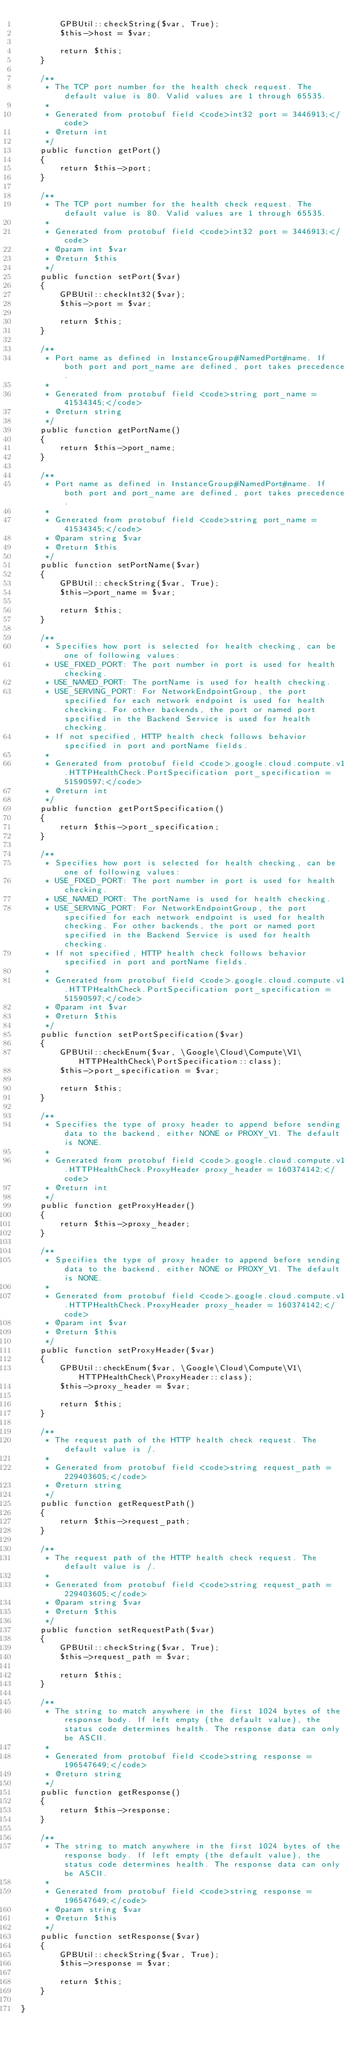<code> <loc_0><loc_0><loc_500><loc_500><_PHP_>        GPBUtil::checkString($var, True);
        $this->host = $var;

        return $this;
    }

    /**
     * The TCP port number for the health check request. The default value is 80. Valid values are 1 through 65535.
     *
     * Generated from protobuf field <code>int32 port = 3446913;</code>
     * @return int
     */
    public function getPort()
    {
        return $this->port;
    }

    /**
     * The TCP port number for the health check request. The default value is 80. Valid values are 1 through 65535.
     *
     * Generated from protobuf field <code>int32 port = 3446913;</code>
     * @param int $var
     * @return $this
     */
    public function setPort($var)
    {
        GPBUtil::checkInt32($var);
        $this->port = $var;

        return $this;
    }

    /**
     * Port name as defined in InstanceGroup#NamedPort#name. If both port and port_name are defined, port takes precedence.
     *
     * Generated from protobuf field <code>string port_name = 41534345;</code>
     * @return string
     */
    public function getPortName()
    {
        return $this->port_name;
    }

    /**
     * Port name as defined in InstanceGroup#NamedPort#name. If both port and port_name are defined, port takes precedence.
     *
     * Generated from protobuf field <code>string port_name = 41534345;</code>
     * @param string $var
     * @return $this
     */
    public function setPortName($var)
    {
        GPBUtil::checkString($var, True);
        $this->port_name = $var;

        return $this;
    }

    /**
     * Specifies how port is selected for health checking, can be one of following values:
     * USE_FIXED_PORT: The port number in port is used for health checking.
     * USE_NAMED_PORT: The portName is used for health checking.
     * USE_SERVING_PORT: For NetworkEndpointGroup, the port specified for each network endpoint is used for health checking. For other backends, the port or named port specified in the Backend Service is used for health checking.
     * If not specified, HTTP health check follows behavior specified in port and portName fields.
     *
     * Generated from protobuf field <code>.google.cloud.compute.v1.HTTPHealthCheck.PortSpecification port_specification = 51590597;</code>
     * @return int
     */
    public function getPortSpecification()
    {
        return $this->port_specification;
    }

    /**
     * Specifies how port is selected for health checking, can be one of following values:
     * USE_FIXED_PORT: The port number in port is used for health checking.
     * USE_NAMED_PORT: The portName is used for health checking.
     * USE_SERVING_PORT: For NetworkEndpointGroup, the port specified for each network endpoint is used for health checking. For other backends, the port or named port specified in the Backend Service is used for health checking.
     * If not specified, HTTP health check follows behavior specified in port and portName fields.
     *
     * Generated from protobuf field <code>.google.cloud.compute.v1.HTTPHealthCheck.PortSpecification port_specification = 51590597;</code>
     * @param int $var
     * @return $this
     */
    public function setPortSpecification($var)
    {
        GPBUtil::checkEnum($var, \Google\Cloud\Compute\V1\HTTPHealthCheck\PortSpecification::class);
        $this->port_specification = $var;

        return $this;
    }

    /**
     * Specifies the type of proxy header to append before sending data to the backend, either NONE or PROXY_V1. The default is NONE.
     *
     * Generated from protobuf field <code>.google.cloud.compute.v1.HTTPHealthCheck.ProxyHeader proxy_header = 160374142;</code>
     * @return int
     */
    public function getProxyHeader()
    {
        return $this->proxy_header;
    }

    /**
     * Specifies the type of proxy header to append before sending data to the backend, either NONE or PROXY_V1. The default is NONE.
     *
     * Generated from protobuf field <code>.google.cloud.compute.v1.HTTPHealthCheck.ProxyHeader proxy_header = 160374142;</code>
     * @param int $var
     * @return $this
     */
    public function setProxyHeader($var)
    {
        GPBUtil::checkEnum($var, \Google\Cloud\Compute\V1\HTTPHealthCheck\ProxyHeader::class);
        $this->proxy_header = $var;

        return $this;
    }

    /**
     * The request path of the HTTP health check request. The default value is /.
     *
     * Generated from protobuf field <code>string request_path = 229403605;</code>
     * @return string
     */
    public function getRequestPath()
    {
        return $this->request_path;
    }

    /**
     * The request path of the HTTP health check request. The default value is /.
     *
     * Generated from protobuf field <code>string request_path = 229403605;</code>
     * @param string $var
     * @return $this
     */
    public function setRequestPath($var)
    {
        GPBUtil::checkString($var, True);
        $this->request_path = $var;

        return $this;
    }

    /**
     * The string to match anywhere in the first 1024 bytes of the response body. If left empty (the default value), the status code determines health. The response data can only be ASCII.
     *
     * Generated from protobuf field <code>string response = 196547649;</code>
     * @return string
     */
    public function getResponse()
    {
        return $this->response;
    }

    /**
     * The string to match anywhere in the first 1024 bytes of the response body. If left empty (the default value), the status code determines health. The response data can only be ASCII.
     *
     * Generated from protobuf field <code>string response = 196547649;</code>
     * @param string $var
     * @return $this
     */
    public function setResponse($var)
    {
        GPBUtil::checkString($var, True);
        $this->response = $var;

        return $this;
    }

}

</code> 